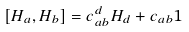<formula> <loc_0><loc_0><loc_500><loc_500>[ H _ { a } , H _ { b } ] = c _ { a b } ^ { d } H _ { d } + c _ { a b } 1</formula> 